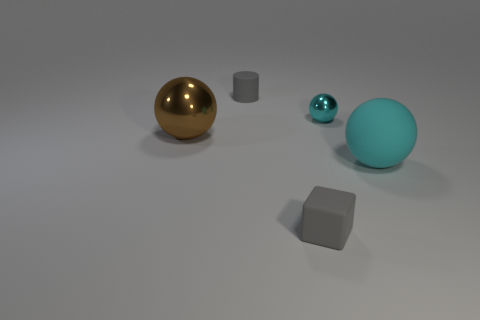The cyan object in front of the metallic object on the left side of the gray rubber object in front of the big cyan ball is made of what material?
Provide a succinct answer. Rubber. How many spheres are either big metal things or tiny shiny things?
Offer a very short reply. 2. What number of spheres are to the right of the shiny sphere to the right of the tiny matte object behind the brown shiny object?
Your response must be concise. 1. Does the small metal thing have the same shape as the brown metallic object?
Make the answer very short. Yes. Does the sphere that is on the right side of the small ball have the same material as the thing on the left side of the gray cylinder?
Provide a short and direct response. No. How many objects are either spheres behind the big cyan matte object or matte things that are in front of the gray matte cylinder?
Offer a terse response. 4. Is there anything else that is the same shape as the brown object?
Keep it short and to the point. Yes. How many tiny gray matte blocks are there?
Your response must be concise. 1. Are there any yellow metal cubes of the same size as the brown metallic sphere?
Provide a succinct answer. No. Does the tiny gray cylinder have the same material as the gray thing that is in front of the gray rubber cylinder?
Your answer should be compact. Yes. 